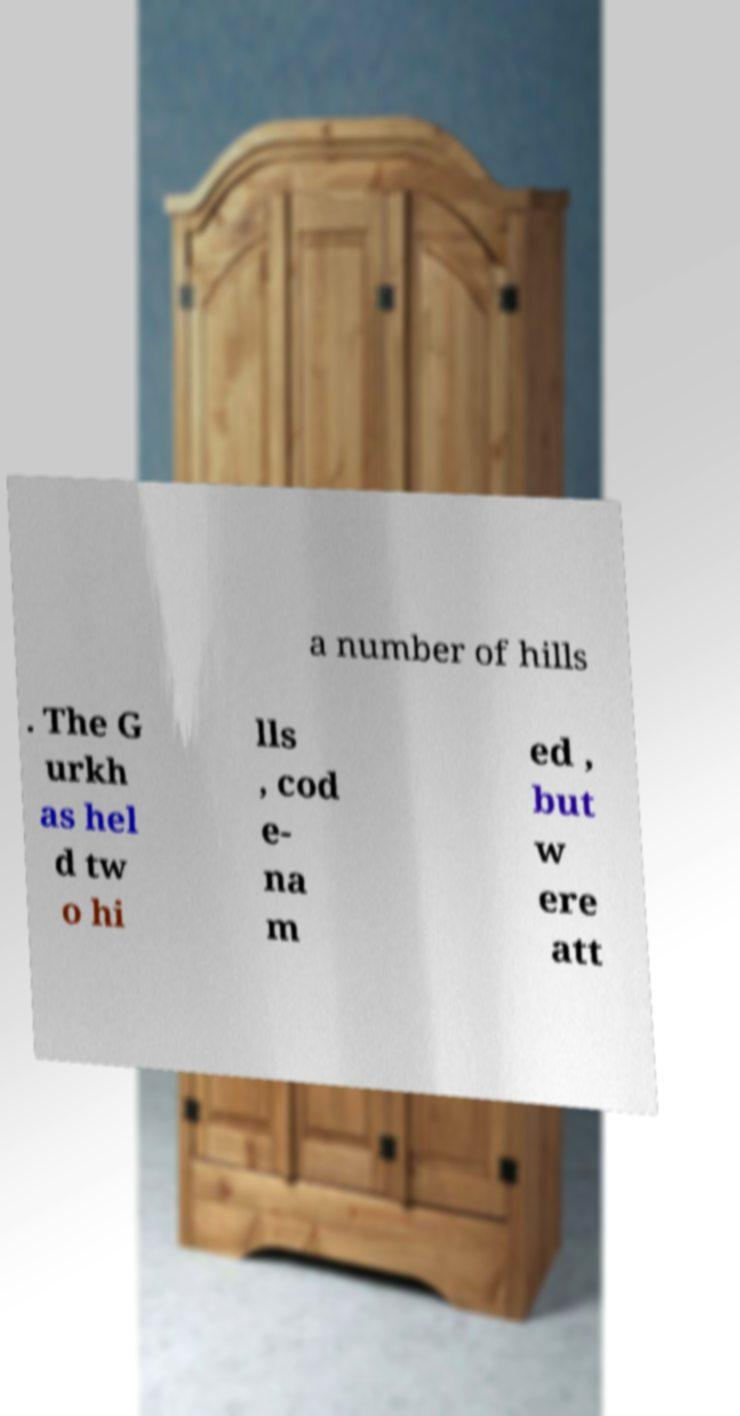There's text embedded in this image that I need extracted. Can you transcribe it verbatim? a number of hills . The G urkh as hel d tw o hi lls , cod e- na m ed , but w ere att 